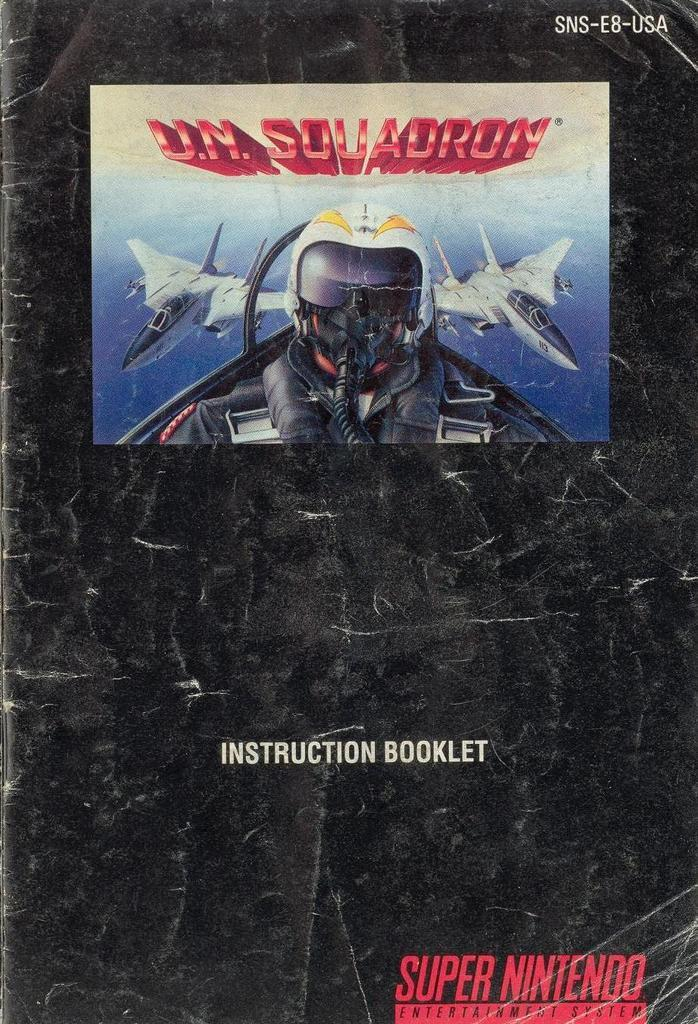<image>
Write a terse but informative summary of the picture. A poster for a Super Nintendo game called U.N. Squadron. 